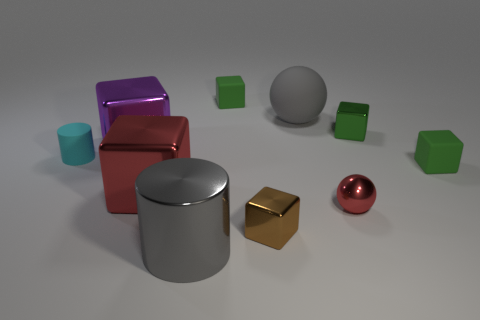How many big objects are in front of the tiny ball and behind the metallic cylinder?
Provide a short and direct response. 0. There is a block that is behind the green shiny block; how many gray matte spheres are to the left of it?
Provide a short and direct response. 0. Is the size of the cylinder that is on the left side of the large cylinder the same as the gray object that is behind the small brown metal cube?
Your answer should be very brief. No. What number of tiny red shiny things are there?
Keep it short and to the point. 1. How many tiny brown objects are the same material as the tiny brown cube?
Give a very brief answer. 0. Are there an equal number of metal cubes that are on the right side of the small green metallic cube and small green matte cylinders?
Your response must be concise. Yes. What is the material of the large thing that is the same color as the metallic ball?
Give a very brief answer. Metal. There is a cyan rubber thing; is it the same size as the sphere that is behind the cyan rubber thing?
Ensure brevity in your answer.  No. What number of other objects are the same size as the cyan rubber object?
Offer a terse response. 5. How many other things are the same color as the metallic cylinder?
Give a very brief answer. 1. 